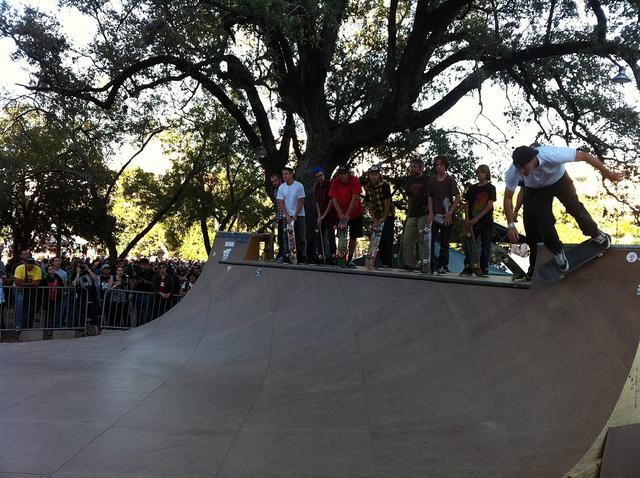How many people are on the ramp?

Choices:
A) four
B) two
C) one
D) many many 